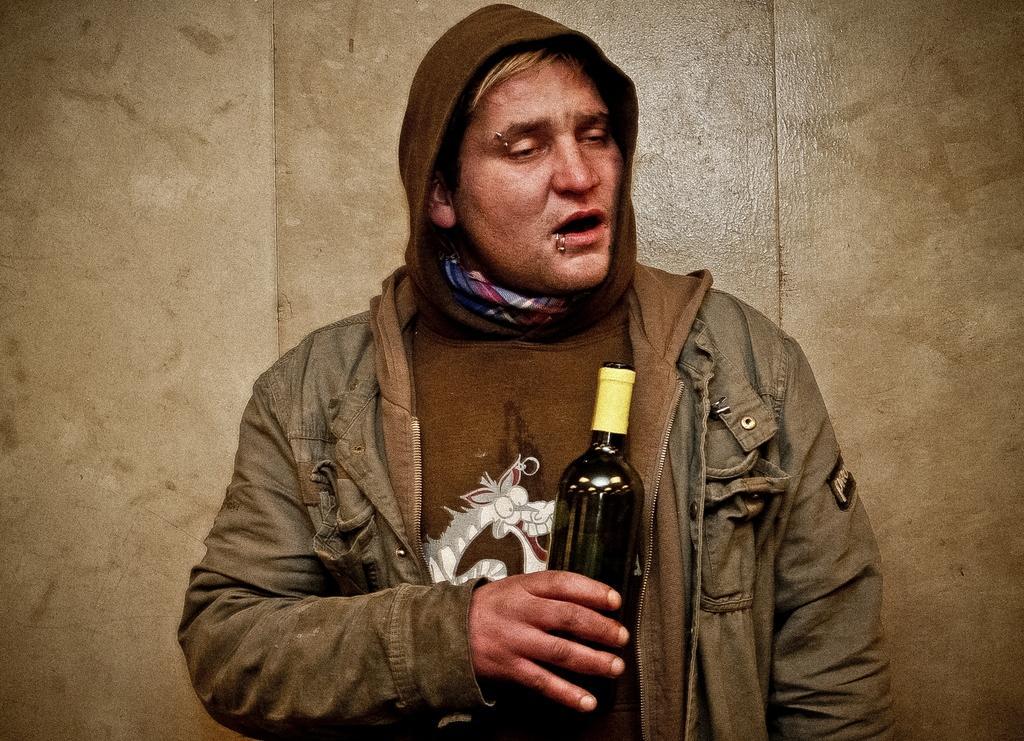Could you give a brief overview of what you see in this image? Here we can see a person is standing and holding a wine bottle in his hands, and at back here is the wall. 